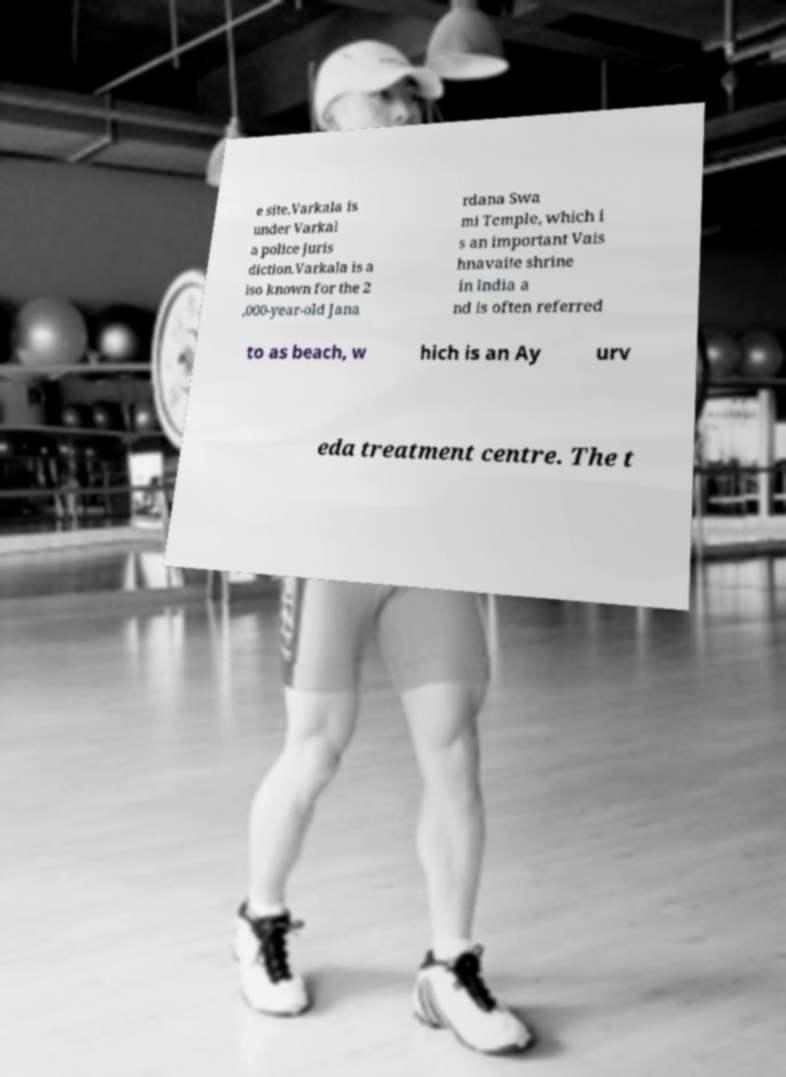What messages or text are displayed in this image? I need them in a readable, typed format. e site.Varkala is under Varkal a police juris diction.Varkala is a lso known for the 2 ,000-year-old Jana rdana Swa mi Temple, which i s an important Vais hnavaite shrine in India a nd is often referred to as beach, w hich is an Ay urv eda treatment centre. The t 